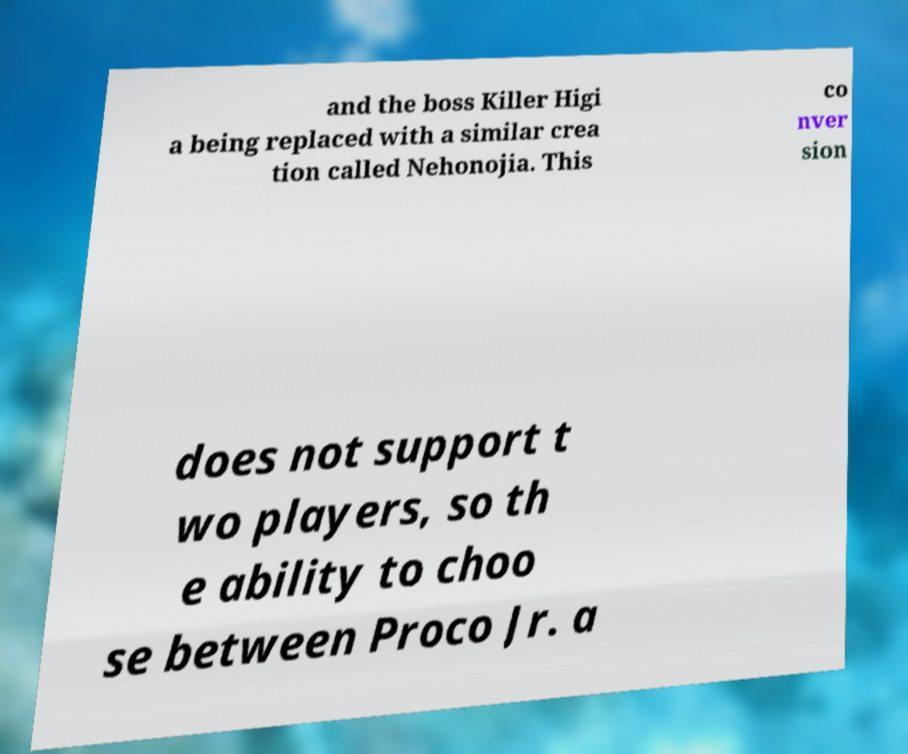Can you accurately transcribe the text from the provided image for me? and the boss Killer Higi a being replaced with a similar crea tion called Nehonojia. This co nver sion does not support t wo players, so th e ability to choo se between Proco Jr. a 